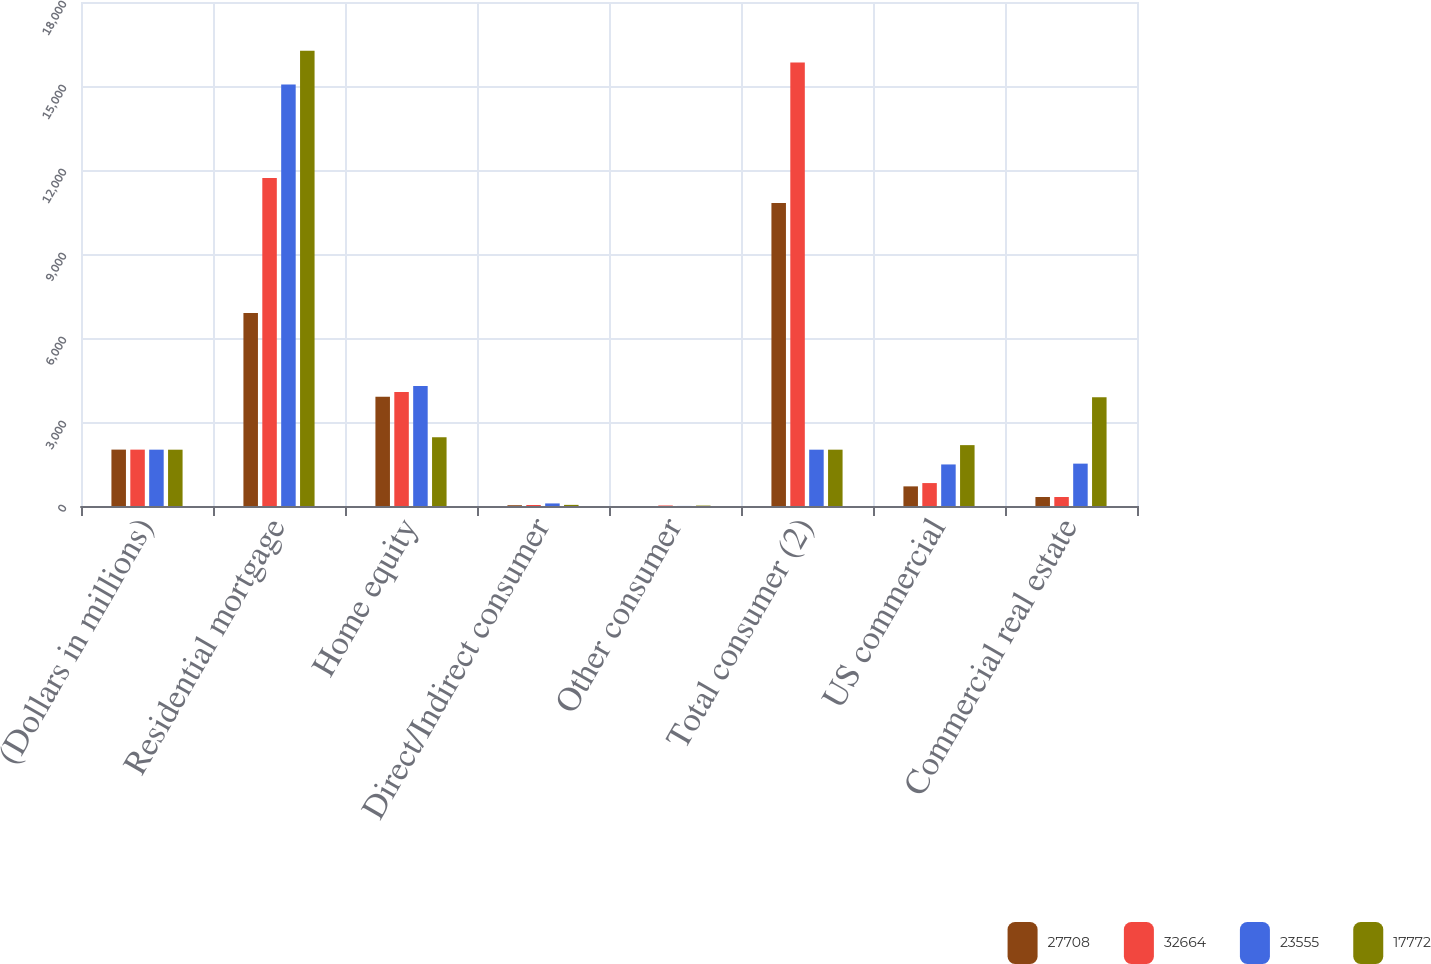<chart> <loc_0><loc_0><loc_500><loc_500><stacked_bar_chart><ecel><fcel>(Dollars in millions)<fcel>Residential mortgage<fcel>Home equity<fcel>Direct/Indirect consumer<fcel>Other consumer<fcel>Total consumer (2)<fcel>US commercial<fcel>Commercial real estate<nl><fcel>27708<fcel>2014<fcel>6889<fcel>3901<fcel>28<fcel>1<fcel>10819<fcel>701<fcel>321<nl><fcel>32664<fcel>2013<fcel>11712<fcel>4075<fcel>35<fcel>18<fcel>15840<fcel>819<fcel>322<nl><fcel>23555<fcel>2012<fcel>15055<fcel>4282<fcel>92<fcel>2<fcel>2011.5<fcel>1484<fcel>1513<nl><fcel>17772<fcel>2011<fcel>16259<fcel>2454<fcel>40<fcel>15<fcel>2011.5<fcel>2174<fcel>3880<nl></chart> 